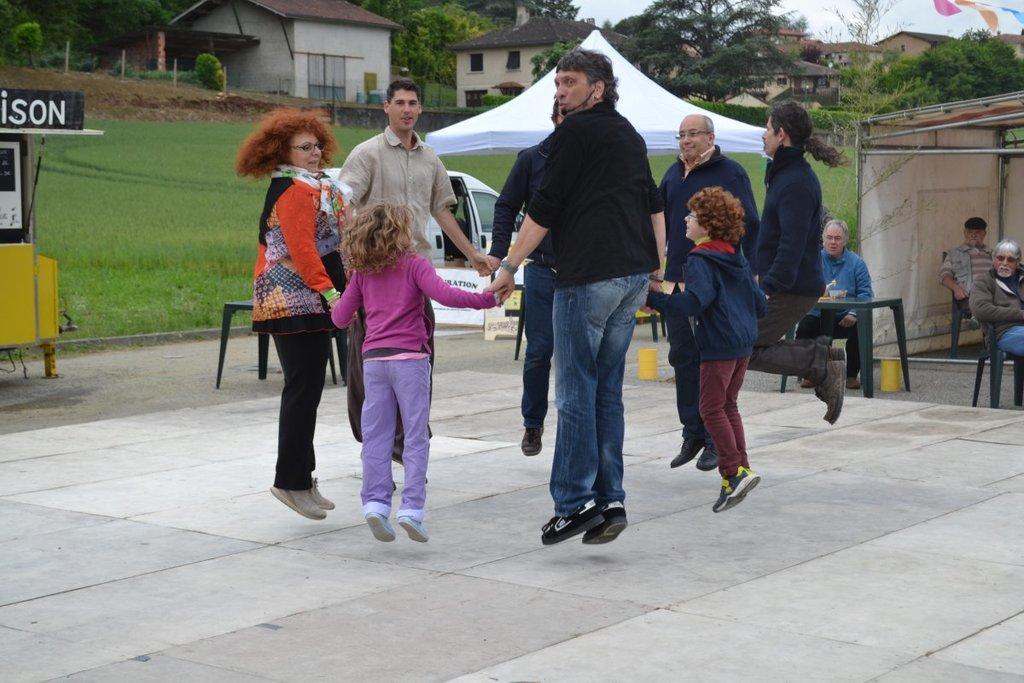How would you summarize this image in a sentence or two? In the center of the image we can see people holding their hands and jumping. We can see some of them are sitting and there is a table. In the background there is a tent, car, grass and buildings. At the top there is sky. 